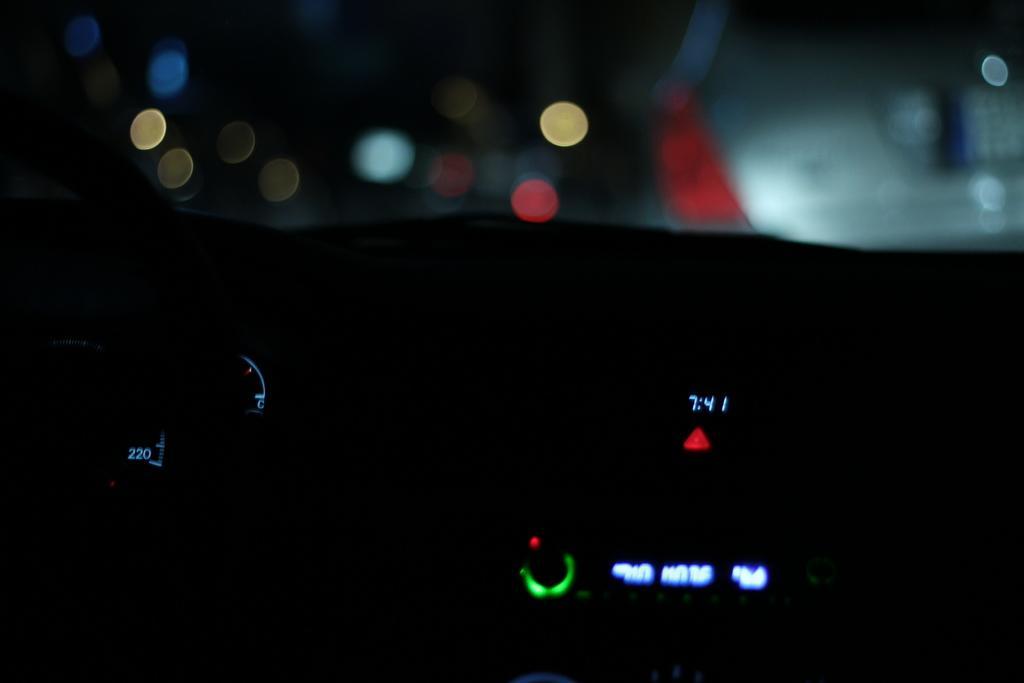In one or two sentences, can you explain what this image depicts? In this image we can see a speedometer, a clock and in the background, we can see a car and some light. 